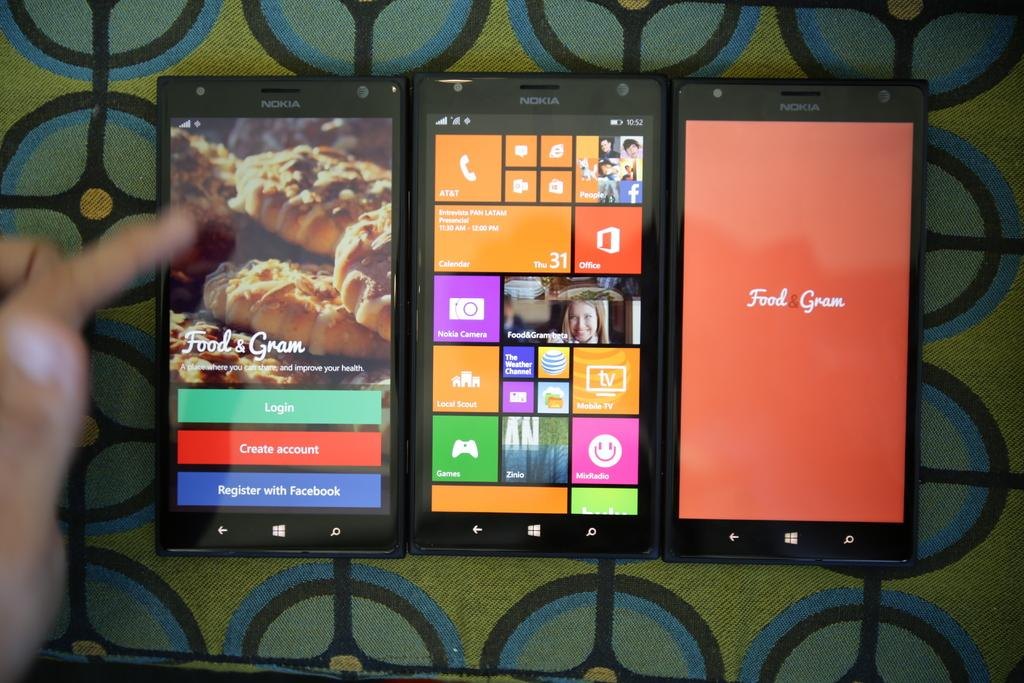<image>
Give a short and clear explanation of the subsequent image. An app called Food & Gram is displayed on three cell phones. 